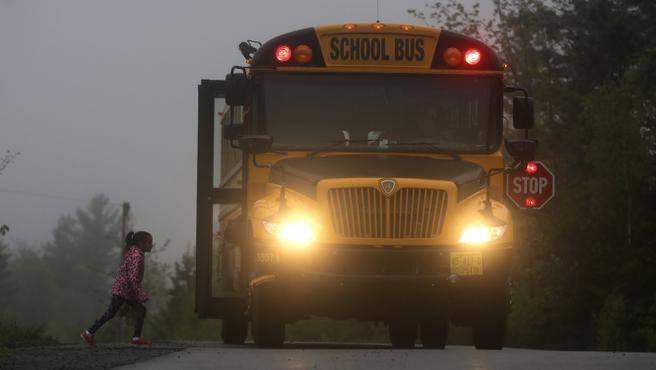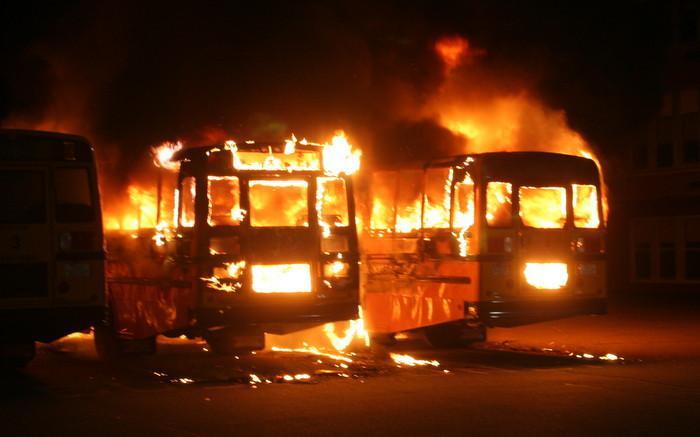The first image is the image on the left, the second image is the image on the right. Assess this claim about the two images: "At least one school bus is on fire in only one of the images.". Correct or not? Answer yes or no. Yes. The first image is the image on the left, the second image is the image on the right. Evaluate the accuracy of this statement regarding the images: "One image shows a school bus on fire, and the other does not.". Is it true? Answer yes or no. Yes. 